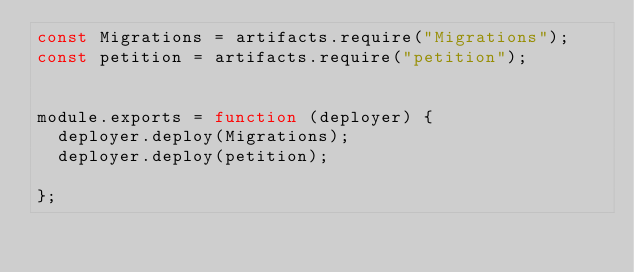Convert code to text. <code><loc_0><loc_0><loc_500><loc_500><_JavaScript_>const Migrations = artifacts.require("Migrations");
const petition = artifacts.require("petition");


module.exports = function (deployer) {
  deployer.deploy(Migrations);
  deployer.deploy(petition);
  
};
</code> 